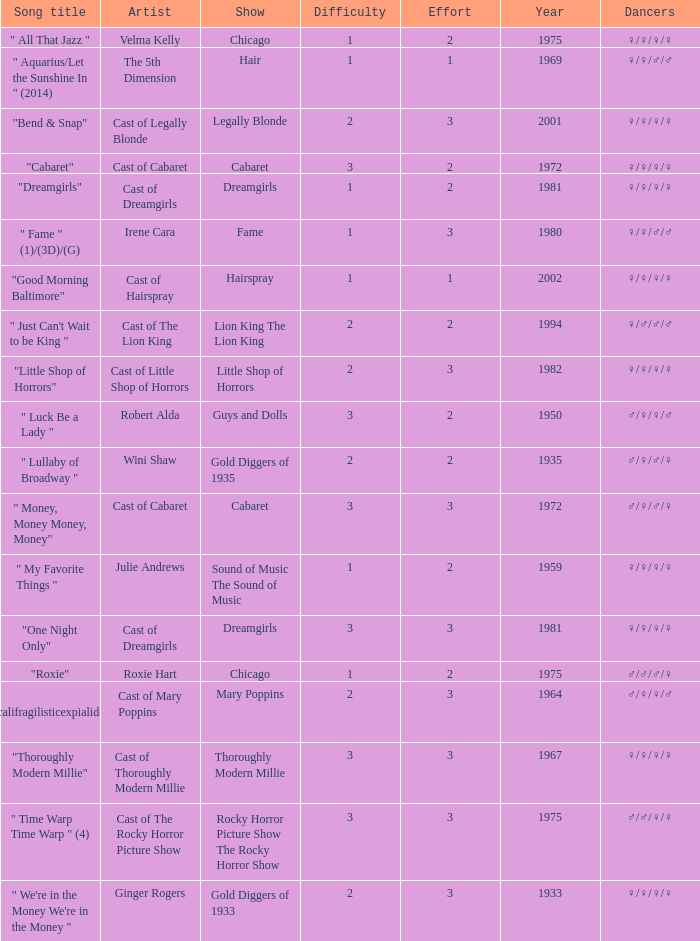Which show highlighted the track "little shop of horrors"? Little Shop of Horrors. 